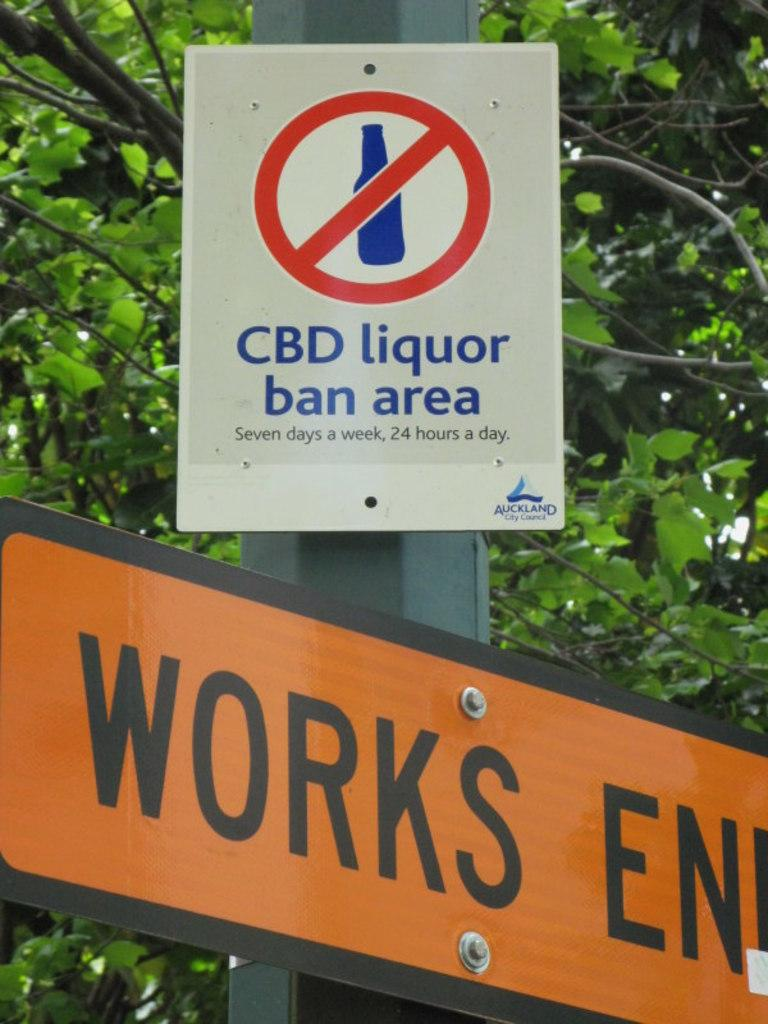What is the main structure in the image? There are two boards attached to a pole in the image. What is written or depicted on the boards? There is text on the boards. What can be seen in the background of the image? There is a tree in the background of the image. Where can the mint plant be found in the image? There is no mint plant present in the image. What type of ant is crawling on the pole in the image? There are no ants present in the image. 